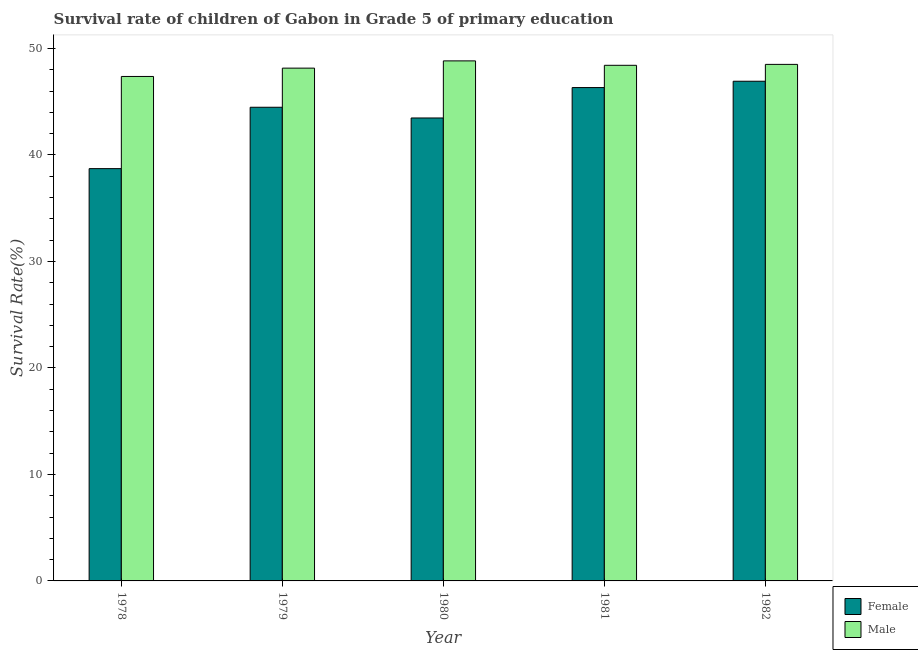How many groups of bars are there?
Your answer should be compact. 5. How many bars are there on the 1st tick from the right?
Offer a terse response. 2. In how many cases, is the number of bars for a given year not equal to the number of legend labels?
Make the answer very short. 0. What is the survival rate of female students in primary education in 1979?
Provide a succinct answer. 44.48. Across all years, what is the maximum survival rate of male students in primary education?
Offer a terse response. 48.83. Across all years, what is the minimum survival rate of female students in primary education?
Provide a short and direct response. 38.71. In which year was the survival rate of female students in primary education maximum?
Your response must be concise. 1982. In which year was the survival rate of male students in primary education minimum?
Keep it short and to the point. 1978. What is the total survival rate of female students in primary education in the graph?
Offer a very short reply. 219.9. What is the difference between the survival rate of female students in primary education in 1979 and that in 1981?
Ensure brevity in your answer.  -1.85. What is the difference between the survival rate of female students in primary education in 1978 and the survival rate of male students in primary education in 1980?
Offer a terse response. -4.76. What is the average survival rate of female students in primary education per year?
Provide a succinct answer. 43.98. In the year 1981, what is the difference between the survival rate of female students in primary education and survival rate of male students in primary education?
Keep it short and to the point. 0. In how many years, is the survival rate of female students in primary education greater than 30 %?
Your answer should be compact. 5. What is the ratio of the survival rate of female students in primary education in 1979 to that in 1982?
Give a very brief answer. 0.95. Is the survival rate of female students in primary education in 1978 less than that in 1981?
Offer a terse response. Yes. Is the difference between the survival rate of female students in primary education in 1979 and 1980 greater than the difference between the survival rate of male students in primary education in 1979 and 1980?
Give a very brief answer. No. What is the difference between the highest and the second highest survival rate of female students in primary education?
Give a very brief answer. 0.59. What is the difference between the highest and the lowest survival rate of female students in primary education?
Provide a short and direct response. 8.21. In how many years, is the survival rate of female students in primary education greater than the average survival rate of female students in primary education taken over all years?
Make the answer very short. 3. Is the sum of the survival rate of female students in primary education in 1980 and 1981 greater than the maximum survival rate of male students in primary education across all years?
Your answer should be very brief. Yes. What does the 1st bar from the left in 1982 represents?
Offer a terse response. Female. How many bars are there?
Provide a short and direct response. 10. Are all the bars in the graph horizontal?
Your answer should be very brief. No. How many years are there in the graph?
Keep it short and to the point. 5. What is the difference between two consecutive major ticks on the Y-axis?
Keep it short and to the point. 10. Does the graph contain any zero values?
Give a very brief answer. No. How many legend labels are there?
Keep it short and to the point. 2. How are the legend labels stacked?
Ensure brevity in your answer.  Vertical. What is the title of the graph?
Ensure brevity in your answer.  Survival rate of children of Gabon in Grade 5 of primary education. Does "Constant 2005 US$" appear as one of the legend labels in the graph?
Give a very brief answer. No. What is the label or title of the X-axis?
Ensure brevity in your answer.  Year. What is the label or title of the Y-axis?
Offer a terse response. Survival Rate(%). What is the Survival Rate(%) of Female in 1978?
Keep it short and to the point. 38.71. What is the Survival Rate(%) of Male in 1978?
Your answer should be very brief. 47.37. What is the Survival Rate(%) in Female in 1979?
Keep it short and to the point. 44.48. What is the Survival Rate(%) of Male in 1979?
Make the answer very short. 48.15. What is the Survival Rate(%) in Female in 1980?
Give a very brief answer. 43.47. What is the Survival Rate(%) in Male in 1980?
Offer a very short reply. 48.83. What is the Survival Rate(%) in Female in 1981?
Offer a very short reply. 46.32. What is the Survival Rate(%) of Male in 1981?
Your response must be concise. 48.41. What is the Survival Rate(%) of Female in 1982?
Your response must be concise. 46.92. What is the Survival Rate(%) in Male in 1982?
Provide a succinct answer. 48.5. Across all years, what is the maximum Survival Rate(%) in Female?
Provide a short and direct response. 46.92. Across all years, what is the maximum Survival Rate(%) of Male?
Offer a terse response. 48.83. Across all years, what is the minimum Survival Rate(%) of Female?
Give a very brief answer. 38.71. Across all years, what is the minimum Survival Rate(%) of Male?
Provide a short and direct response. 47.37. What is the total Survival Rate(%) in Female in the graph?
Your response must be concise. 219.9. What is the total Survival Rate(%) of Male in the graph?
Provide a short and direct response. 241.26. What is the difference between the Survival Rate(%) of Female in 1978 and that in 1979?
Your answer should be compact. -5.76. What is the difference between the Survival Rate(%) of Male in 1978 and that in 1979?
Keep it short and to the point. -0.78. What is the difference between the Survival Rate(%) of Female in 1978 and that in 1980?
Your answer should be compact. -4.76. What is the difference between the Survival Rate(%) of Male in 1978 and that in 1980?
Your answer should be very brief. -1.46. What is the difference between the Survival Rate(%) in Female in 1978 and that in 1981?
Your answer should be compact. -7.61. What is the difference between the Survival Rate(%) in Male in 1978 and that in 1981?
Offer a terse response. -1.05. What is the difference between the Survival Rate(%) in Female in 1978 and that in 1982?
Keep it short and to the point. -8.21. What is the difference between the Survival Rate(%) in Male in 1978 and that in 1982?
Your answer should be compact. -1.14. What is the difference between the Survival Rate(%) of Female in 1979 and that in 1980?
Make the answer very short. 1.01. What is the difference between the Survival Rate(%) in Male in 1979 and that in 1980?
Keep it short and to the point. -0.68. What is the difference between the Survival Rate(%) in Female in 1979 and that in 1981?
Provide a short and direct response. -1.85. What is the difference between the Survival Rate(%) in Male in 1979 and that in 1981?
Provide a succinct answer. -0.26. What is the difference between the Survival Rate(%) in Female in 1979 and that in 1982?
Give a very brief answer. -2.44. What is the difference between the Survival Rate(%) of Male in 1979 and that in 1982?
Your answer should be compact. -0.35. What is the difference between the Survival Rate(%) of Female in 1980 and that in 1981?
Ensure brevity in your answer.  -2.85. What is the difference between the Survival Rate(%) in Male in 1980 and that in 1981?
Offer a terse response. 0.42. What is the difference between the Survival Rate(%) in Female in 1980 and that in 1982?
Offer a terse response. -3.45. What is the difference between the Survival Rate(%) in Male in 1980 and that in 1982?
Make the answer very short. 0.33. What is the difference between the Survival Rate(%) of Female in 1981 and that in 1982?
Make the answer very short. -0.59. What is the difference between the Survival Rate(%) in Male in 1981 and that in 1982?
Your answer should be very brief. -0.09. What is the difference between the Survival Rate(%) in Female in 1978 and the Survival Rate(%) in Male in 1979?
Ensure brevity in your answer.  -9.44. What is the difference between the Survival Rate(%) of Female in 1978 and the Survival Rate(%) of Male in 1980?
Your response must be concise. -10.12. What is the difference between the Survival Rate(%) of Female in 1978 and the Survival Rate(%) of Male in 1981?
Provide a succinct answer. -9.7. What is the difference between the Survival Rate(%) of Female in 1978 and the Survival Rate(%) of Male in 1982?
Your answer should be compact. -9.79. What is the difference between the Survival Rate(%) of Female in 1979 and the Survival Rate(%) of Male in 1980?
Give a very brief answer. -4.35. What is the difference between the Survival Rate(%) of Female in 1979 and the Survival Rate(%) of Male in 1981?
Provide a short and direct response. -3.94. What is the difference between the Survival Rate(%) in Female in 1979 and the Survival Rate(%) in Male in 1982?
Your response must be concise. -4.03. What is the difference between the Survival Rate(%) of Female in 1980 and the Survival Rate(%) of Male in 1981?
Your answer should be very brief. -4.94. What is the difference between the Survival Rate(%) in Female in 1980 and the Survival Rate(%) in Male in 1982?
Ensure brevity in your answer.  -5.03. What is the difference between the Survival Rate(%) of Female in 1981 and the Survival Rate(%) of Male in 1982?
Your response must be concise. -2.18. What is the average Survival Rate(%) in Female per year?
Give a very brief answer. 43.98. What is the average Survival Rate(%) in Male per year?
Make the answer very short. 48.25. In the year 1978, what is the difference between the Survival Rate(%) of Female and Survival Rate(%) of Male?
Ensure brevity in your answer.  -8.65. In the year 1979, what is the difference between the Survival Rate(%) of Female and Survival Rate(%) of Male?
Offer a very short reply. -3.67. In the year 1980, what is the difference between the Survival Rate(%) of Female and Survival Rate(%) of Male?
Your answer should be very brief. -5.36. In the year 1981, what is the difference between the Survival Rate(%) in Female and Survival Rate(%) in Male?
Ensure brevity in your answer.  -2.09. In the year 1982, what is the difference between the Survival Rate(%) in Female and Survival Rate(%) in Male?
Provide a short and direct response. -1.58. What is the ratio of the Survival Rate(%) of Female in 1978 to that in 1979?
Give a very brief answer. 0.87. What is the ratio of the Survival Rate(%) in Male in 1978 to that in 1979?
Keep it short and to the point. 0.98. What is the ratio of the Survival Rate(%) of Female in 1978 to that in 1980?
Keep it short and to the point. 0.89. What is the ratio of the Survival Rate(%) in Male in 1978 to that in 1980?
Give a very brief answer. 0.97. What is the ratio of the Survival Rate(%) of Female in 1978 to that in 1981?
Ensure brevity in your answer.  0.84. What is the ratio of the Survival Rate(%) of Male in 1978 to that in 1981?
Give a very brief answer. 0.98. What is the ratio of the Survival Rate(%) of Female in 1978 to that in 1982?
Ensure brevity in your answer.  0.83. What is the ratio of the Survival Rate(%) of Male in 1978 to that in 1982?
Give a very brief answer. 0.98. What is the ratio of the Survival Rate(%) in Female in 1979 to that in 1980?
Your answer should be very brief. 1.02. What is the ratio of the Survival Rate(%) in Male in 1979 to that in 1980?
Your answer should be very brief. 0.99. What is the ratio of the Survival Rate(%) of Female in 1979 to that in 1981?
Make the answer very short. 0.96. What is the ratio of the Survival Rate(%) of Male in 1979 to that in 1981?
Provide a short and direct response. 0.99. What is the ratio of the Survival Rate(%) in Female in 1979 to that in 1982?
Your response must be concise. 0.95. What is the ratio of the Survival Rate(%) in Female in 1980 to that in 1981?
Your answer should be very brief. 0.94. What is the ratio of the Survival Rate(%) in Male in 1980 to that in 1981?
Provide a succinct answer. 1.01. What is the ratio of the Survival Rate(%) of Female in 1980 to that in 1982?
Make the answer very short. 0.93. What is the ratio of the Survival Rate(%) in Male in 1980 to that in 1982?
Your answer should be very brief. 1.01. What is the ratio of the Survival Rate(%) in Female in 1981 to that in 1982?
Your answer should be compact. 0.99. What is the ratio of the Survival Rate(%) in Male in 1981 to that in 1982?
Give a very brief answer. 1. What is the difference between the highest and the second highest Survival Rate(%) in Female?
Keep it short and to the point. 0.59. What is the difference between the highest and the second highest Survival Rate(%) of Male?
Offer a very short reply. 0.33. What is the difference between the highest and the lowest Survival Rate(%) in Female?
Provide a succinct answer. 8.21. What is the difference between the highest and the lowest Survival Rate(%) in Male?
Ensure brevity in your answer.  1.46. 